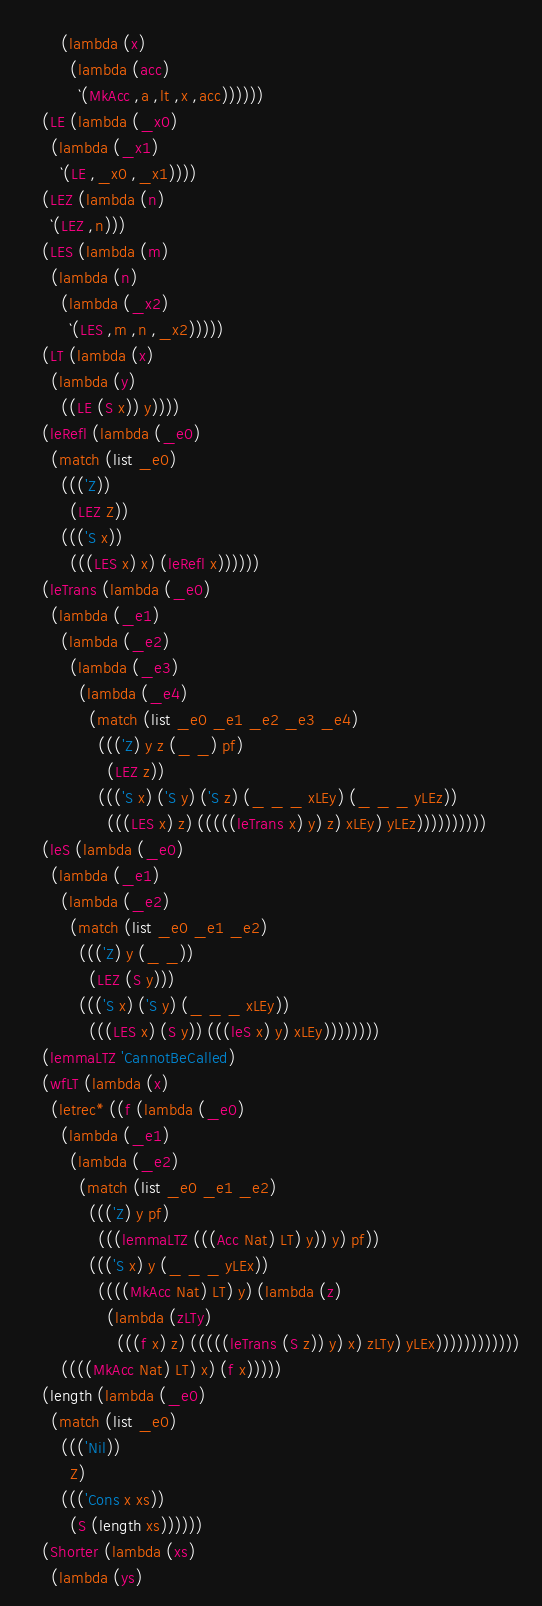<code> <loc_0><loc_0><loc_500><loc_500><_Scheme_>        (lambda (x)
          (lambda (acc)
            `(MkAcc ,a ,lt ,x ,acc))))))
    (LE (lambda (_x0)
      (lambda (_x1)
        `(LE ,_x0 ,_x1))))
    (LEZ (lambda (n)
      `(LEZ ,n)))
    (LES (lambda (m)
      (lambda (n)
        (lambda (_x2)
          `(LES ,m ,n ,_x2)))))
    (LT (lambda (x)
      (lambda (y)
        ((LE (S x)) y))))
    (leRefl (lambda (_e0)
      (match (list _e0)
        ((('Z))
          (LEZ Z))
        ((('S x))
          (((LES x) x) (leRefl x))))))
    (leTrans (lambda (_e0)
      (lambda (_e1)
        (lambda (_e2)
          (lambda (_e3)
            (lambda (_e4)
              (match (list _e0 _e1 _e2 _e3 _e4)
                ((('Z) y z (_ _) pf)
                  (LEZ z))
                ((('S x) ('S y) ('S z) (_ _ _ xLEy) (_ _ _ yLEz))
                  (((LES x) z) (((((leTrans x) y) z) xLEy) yLEz))))))))))
    (leS (lambda (_e0)
      (lambda (_e1)
        (lambda (_e2)
          (match (list _e0 _e1 _e2)
            ((('Z) y (_ _))
              (LEZ (S y)))
            ((('S x) ('S y) (_ _ _ xLEy))
              (((LES x) (S y)) (((leS x) y) xLEy))))))))
    (lemmaLTZ 'CannotBeCalled)
    (wfLT (lambda (x)
      (letrec* ((f (lambda (_e0)
        (lambda (_e1)
          (lambda (_e2)
            (match (list _e0 _e1 _e2)
              ((('Z) y pf)
                (((lemmaLTZ (((Acc Nat) LT) y)) y) pf))
              ((('S x) y (_ _ _ yLEx))
                ((((MkAcc Nat) LT) y) (lambda (z)
                  (lambda (zLTy)
                    (((f x) z) (((((leTrans (S z)) y) x) zLTy) yLEx))))))))))))
        ((((MkAcc Nat) LT) x) (f x)))))
    (length (lambda (_e0)
      (match (list _e0)
        ((('Nil))
          Z)
        ((('Cons x xs))
          (S (length xs))))))
    (Shorter (lambda (xs)
      (lambda (ys)</code> 